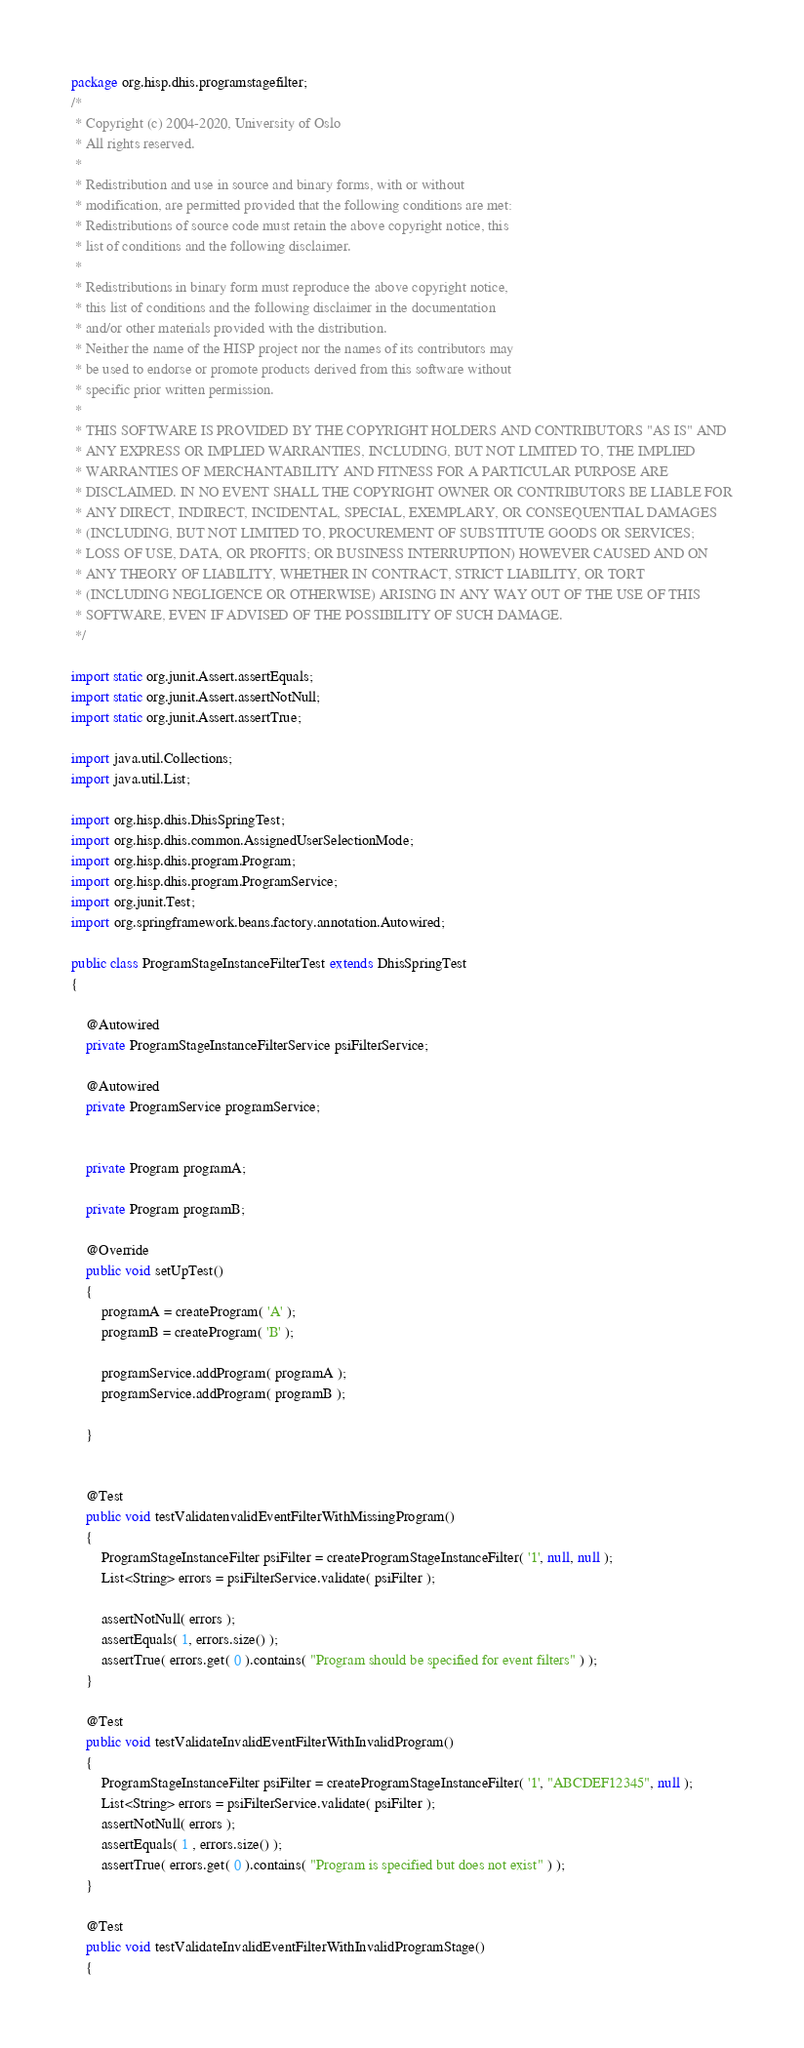<code> <loc_0><loc_0><loc_500><loc_500><_Java_>package org.hisp.dhis.programstagefilter;
/*
 * Copyright (c) 2004-2020, University of Oslo
 * All rights reserved.
 *
 * Redistribution and use in source and binary forms, with or without
 * modification, are permitted provided that the following conditions are met:
 * Redistributions of source code must retain the above copyright notice, this
 * list of conditions and the following disclaimer.
 *
 * Redistributions in binary form must reproduce the above copyright notice,
 * this list of conditions and the following disclaimer in the documentation
 * and/or other materials provided with the distribution.
 * Neither the name of the HISP project nor the names of its contributors may
 * be used to endorse or promote products derived from this software without
 * specific prior written permission.
 *
 * THIS SOFTWARE IS PROVIDED BY THE COPYRIGHT HOLDERS AND CONTRIBUTORS "AS IS" AND
 * ANY EXPRESS OR IMPLIED WARRANTIES, INCLUDING, BUT NOT LIMITED TO, THE IMPLIED
 * WARRANTIES OF MERCHANTABILITY AND FITNESS FOR A PARTICULAR PURPOSE ARE
 * DISCLAIMED. IN NO EVENT SHALL THE COPYRIGHT OWNER OR CONTRIBUTORS BE LIABLE FOR
 * ANY DIRECT, INDIRECT, INCIDENTAL, SPECIAL, EXEMPLARY, OR CONSEQUENTIAL DAMAGES
 * (INCLUDING, BUT NOT LIMITED TO, PROCUREMENT OF SUBSTITUTE GOODS OR SERVICES;
 * LOSS OF USE, DATA, OR PROFITS; OR BUSINESS INTERRUPTION) HOWEVER CAUSED AND ON
 * ANY THEORY OF LIABILITY, WHETHER IN CONTRACT, STRICT LIABILITY, OR TORT
 * (INCLUDING NEGLIGENCE OR OTHERWISE) ARISING IN ANY WAY OUT OF THE USE OF THIS
 * SOFTWARE, EVEN IF ADVISED OF THE POSSIBILITY OF SUCH DAMAGE.
 */

import static org.junit.Assert.assertEquals;
import static org.junit.Assert.assertNotNull;
import static org.junit.Assert.assertTrue;

import java.util.Collections;
import java.util.List;

import org.hisp.dhis.DhisSpringTest;
import org.hisp.dhis.common.AssignedUserSelectionMode;
import org.hisp.dhis.program.Program;
import org.hisp.dhis.program.ProgramService;
import org.junit.Test;
import org.springframework.beans.factory.annotation.Autowired;

public class ProgramStageInstanceFilterTest extends DhisSpringTest
{

    @Autowired
    private ProgramStageInstanceFilterService psiFilterService;

    @Autowired
    private ProgramService programService;


    private Program programA;

    private Program programB;

    @Override
    public void setUpTest()
    {
        programA = createProgram( 'A' );
        programB = createProgram( 'B' );

        programService.addProgram( programA );
        programService.addProgram( programB );

    }


    @Test
    public void testValidatenvalidEventFilterWithMissingProgram()
    {
        ProgramStageInstanceFilter psiFilter = createProgramStageInstanceFilter( '1', null, null );
        List<String> errors = psiFilterService.validate( psiFilter );
        
        assertNotNull( errors );
        assertEquals( 1, errors.size() );
        assertTrue( errors.get( 0 ).contains( "Program should be specified for event filters" ) );
    }

    @Test
    public void testValidateInvalidEventFilterWithInvalidProgram()
    {
        ProgramStageInstanceFilter psiFilter = createProgramStageInstanceFilter( '1', "ABCDEF12345", null );
        List<String> errors = psiFilterService.validate( psiFilter );
        assertNotNull( errors );
        assertEquals( 1 , errors.size() );
        assertTrue( errors.get( 0 ).contains( "Program is specified but does not exist" ) );
    }
    
    @Test
    public void testValidateInvalidEventFilterWithInvalidProgramStage()
    {</code> 